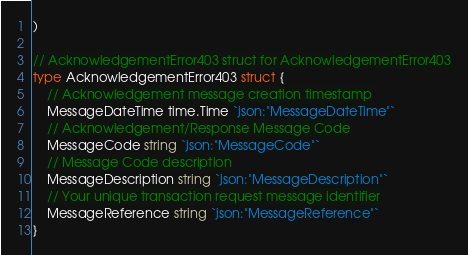<code> <loc_0><loc_0><loc_500><loc_500><_Go_>)

// AcknowledgementError403 struct for AcknowledgementError403
type AcknowledgementError403 struct {
	// Acknowledgement message creation timestamp
	MessageDateTime time.Time `json:"MessageDateTime"`
	// Acknowledgement/Response Message Code
	MessageCode string `json:"MessageCode"`
	// Message Code description
	MessageDescription string `json:"MessageDescription"`
	// Your unique transaction request message identifier
	MessageReference string `json:"MessageReference"`
}
</code> 